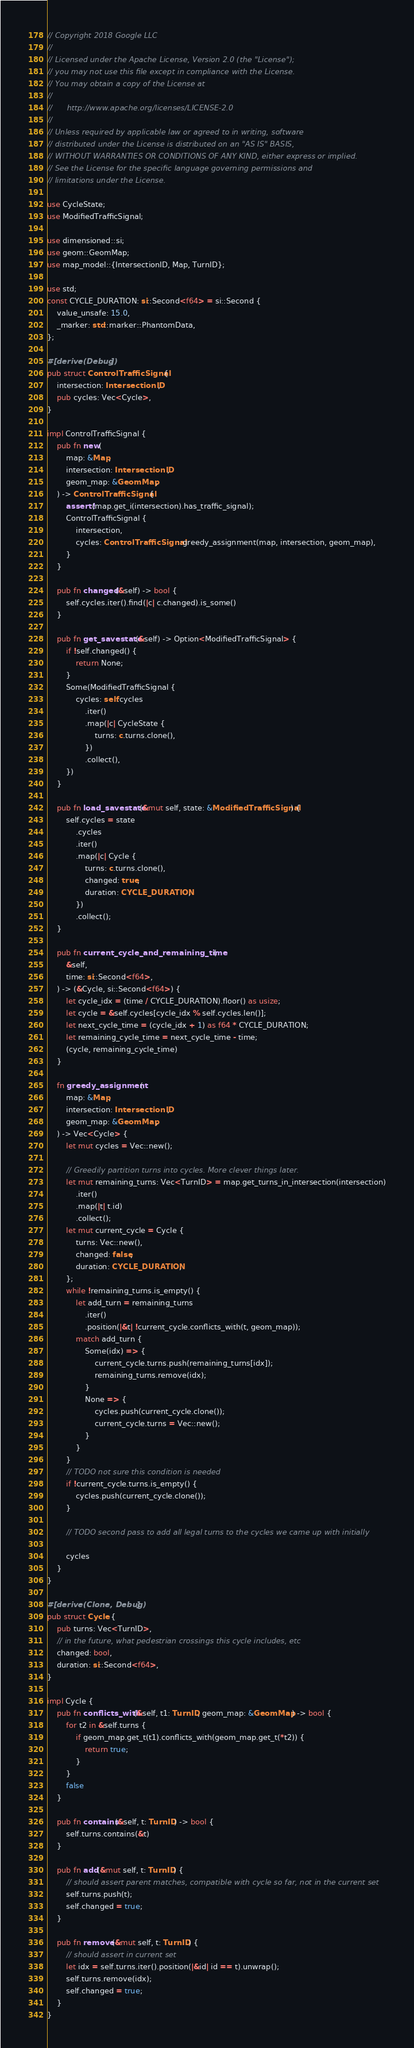<code> <loc_0><loc_0><loc_500><loc_500><_Rust_>// Copyright 2018 Google LLC
//
// Licensed under the Apache License, Version 2.0 (the "License");
// you may not use this file except in compliance with the License.
// You may obtain a copy of the License at
//
//      http://www.apache.org/licenses/LICENSE-2.0
//
// Unless required by applicable law or agreed to in writing, software
// distributed under the License is distributed on an "AS IS" BASIS,
// WITHOUT WARRANTIES OR CONDITIONS OF ANY KIND, either express or implied.
// See the License for the specific language governing permissions and
// limitations under the License.

use CycleState;
use ModifiedTrafficSignal;

use dimensioned::si;
use geom::GeomMap;
use map_model::{IntersectionID, Map, TurnID};

use std;
const CYCLE_DURATION: si::Second<f64> = si::Second {
    value_unsafe: 15.0,
    _marker: std::marker::PhantomData,
};

#[derive(Debug)]
pub struct ControlTrafficSignal {
    intersection: IntersectionID,
    pub cycles: Vec<Cycle>,
}

impl ControlTrafficSignal {
    pub fn new(
        map: &Map,
        intersection: IntersectionID,
        geom_map: &GeomMap,
    ) -> ControlTrafficSignal {
        assert!(map.get_i(intersection).has_traffic_signal);
        ControlTrafficSignal {
            intersection,
            cycles: ControlTrafficSignal::greedy_assignment(map, intersection, geom_map),
        }
    }

    pub fn changed(&self) -> bool {
        self.cycles.iter().find(|c| c.changed).is_some()
    }

    pub fn get_savestate(&self) -> Option<ModifiedTrafficSignal> {
        if !self.changed() {
            return None;
        }
        Some(ModifiedTrafficSignal {
            cycles: self.cycles
                .iter()
                .map(|c| CycleState {
                    turns: c.turns.clone(),
                })
                .collect(),
        })
    }

    pub fn load_savestate(&mut self, state: &ModifiedTrafficSignal) {
        self.cycles = state
            .cycles
            .iter()
            .map(|c| Cycle {
                turns: c.turns.clone(),
                changed: true,
                duration: CYCLE_DURATION,
            })
            .collect();
    }

    pub fn current_cycle_and_remaining_time(
        &self,
        time: si::Second<f64>,
    ) -> (&Cycle, si::Second<f64>) {
        let cycle_idx = (time / CYCLE_DURATION).floor() as usize;
        let cycle = &self.cycles[cycle_idx % self.cycles.len()];
        let next_cycle_time = (cycle_idx + 1) as f64 * CYCLE_DURATION;
        let remaining_cycle_time = next_cycle_time - time;
        (cycle, remaining_cycle_time)
    }

    fn greedy_assignment(
        map: &Map,
        intersection: IntersectionID,
        geom_map: &GeomMap,
    ) -> Vec<Cycle> {
        let mut cycles = Vec::new();

        // Greedily partition turns into cycles. More clever things later.
        let mut remaining_turns: Vec<TurnID> = map.get_turns_in_intersection(intersection)
            .iter()
            .map(|t| t.id)
            .collect();
        let mut current_cycle = Cycle {
            turns: Vec::new(),
            changed: false,
            duration: CYCLE_DURATION,
        };
        while !remaining_turns.is_empty() {
            let add_turn = remaining_turns
                .iter()
                .position(|&t| !current_cycle.conflicts_with(t, geom_map));
            match add_turn {
                Some(idx) => {
                    current_cycle.turns.push(remaining_turns[idx]);
                    remaining_turns.remove(idx);
                }
                None => {
                    cycles.push(current_cycle.clone());
                    current_cycle.turns = Vec::new();
                }
            }
        }
        // TODO not sure this condition is needed
        if !current_cycle.turns.is_empty() {
            cycles.push(current_cycle.clone());
        }

        // TODO second pass to add all legal turns to the cycles we came up with initially

        cycles
    }
}

#[derive(Clone, Debug)]
pub struct Cycle {
    pub turns: Vec<TurnID>,
    // in the future, what pedestrian crossings this cycle includes, etc
    changed: bool,
    duration: si::Second<f64>,
}

impl Cycle {
    pub fn conflicts_with(&self, t1: TurnID, geom_map: &GeomMap) -> bool {
        for t2 in &self.turns {
            if geom_map.get_t(t1).conflicts_with(geom_map.get_t(*t2)) {
                return true;
            }
        }
        false
    }

    pub fn contains(&self, t: TurnID) -> bool {
        self.turns.contains(&t)
    }

    pub fn add(&mut self, t: TurnID) {
        // should assert parent matches, compatible with cycle so far, not in the current set
        self.turns.push(t);
        self.changed = true;
    }

    pub fn remove(&mut self, t: TurnID) {
        // should assert in current set
        let idx = self.turns.iter().position(|&id| id == t).unwrap();
        self.turns.remove(idx);
        self.changed = true;
    }
}
</code> 